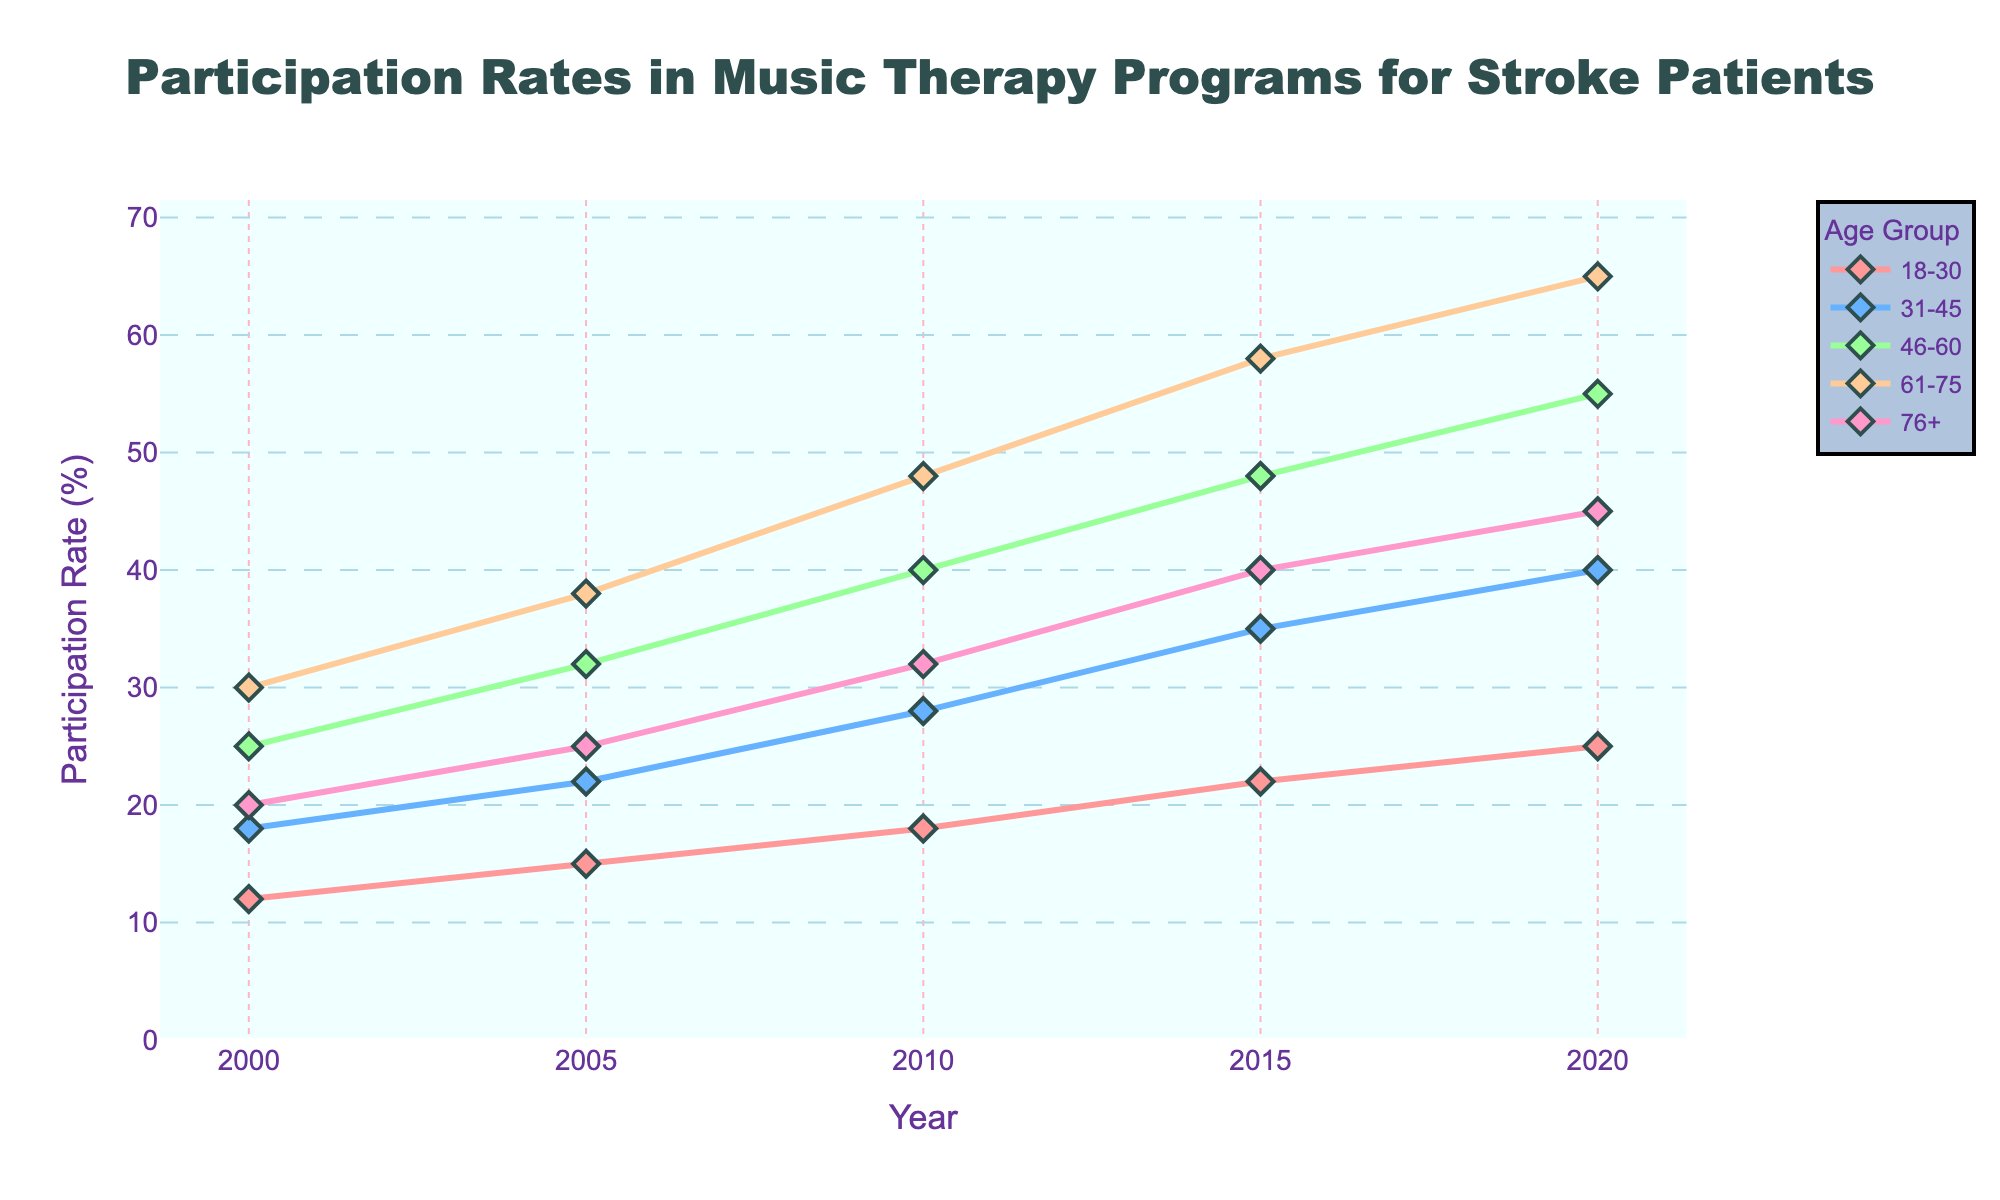What is the trend in participation rates for the age group 31-45 from 2000 to 2020? Look at the line representing the age group 31-45. From 2000 to 2020, the participation rate increases progressively from 18 to 40.
Answer: Increasing In which year did the age group 61-75 have a higher participation rate than the age group 46-60? Compare the lines for age groups 61-75 and 46-60. The age group 61-75 had a higher participation rate in 2020.
Answer: 2020 Which age group had the lowest participation rate in 2000, and what was it? Check the figures for each age group in 2000. The age group 18-30 had the lowest participation rate in 2000 with a value of 12.
Answer: 18-30, 12 What is the average participation rate for the age group 18-30 across all years presented? Sum the participation rates for the age group 18-30 and divide by the number of years (12 + 15 + 18 + 22 + 25) / 5. This equals 18.4.
Answer: 18.4 How much did the participation rate for the age group 46-60 increase from 2000 to 2020? Subtract the 2000 value from the 2020 value for the age group 46-60. (55 - 25).
Answer: 30 Which age group showed the greatest increase in participation rate from 2000 to 2020? Subtract the 2000 participation rate from the 2020 rate for each age group and find the highest value. The age group 61-75 increased the most (65 - 30).
Answer: 61-75 By how many percentage points did the participation rate in the age group 76+ increase from 2010 to 2020? Subtract the participation rate in 2010 from the rate in 2020 for the age group 76+. (45 - 32).
Answer: 13 Which age group had the highest participation rate in 2015 and what was the value? Look at the 2015 values for all age groups and find the highest. The age group 61-75 had the highest participation rate with 58.
Answer: 61-75, 58 What is the total participation rate for all age groups combined in the year 2010? Sum the participation rates of all age groups for the year 2010. (18 + 28 + 40 + 48 + 32).
Answer: 166 Is there any year where two or more age groups had the same participation rate? Compare the participation rates for all age groups across the years. There is no year where two or more age groups had the same participation rate.
Answer: No 